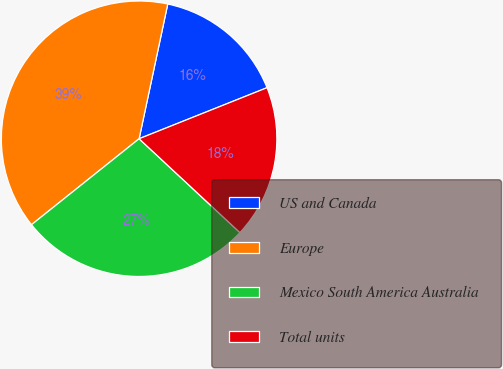<chart> <loc_0><loc_0><loc_500><loc_500><pie_chart><fcel>US and Canada<fcel>Europe<fcel>Mexico South America Australia<fcel>Total units<nl><fcel>15.62%<fcel>39.06%<fcel>27.34%<fcel>17.97%<nl></chart> 